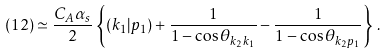Convert formula to latex. <formula><loc_0><loc_0><loc_500><loc_500>( 1 2 ) \simeq \frac { C _ { A } \alpha _ { s } } { 2 } \left \{ ( k _ { 1 } | p _ { 1 } ) + \frac { 1 } { 1 - \cos \theta _ { k _ { 2 } k _ { 1 } } } - \frac { 1 } { 1 - \cos \theta _ { k _ { 2 } p _ { 1 } } } \right \} \, .</formula> 